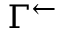Convert formula to latex. <formula><loc_0><loc_0><loc_500><loc_500>\Gamma ^ { \leftarrow }</formula> 